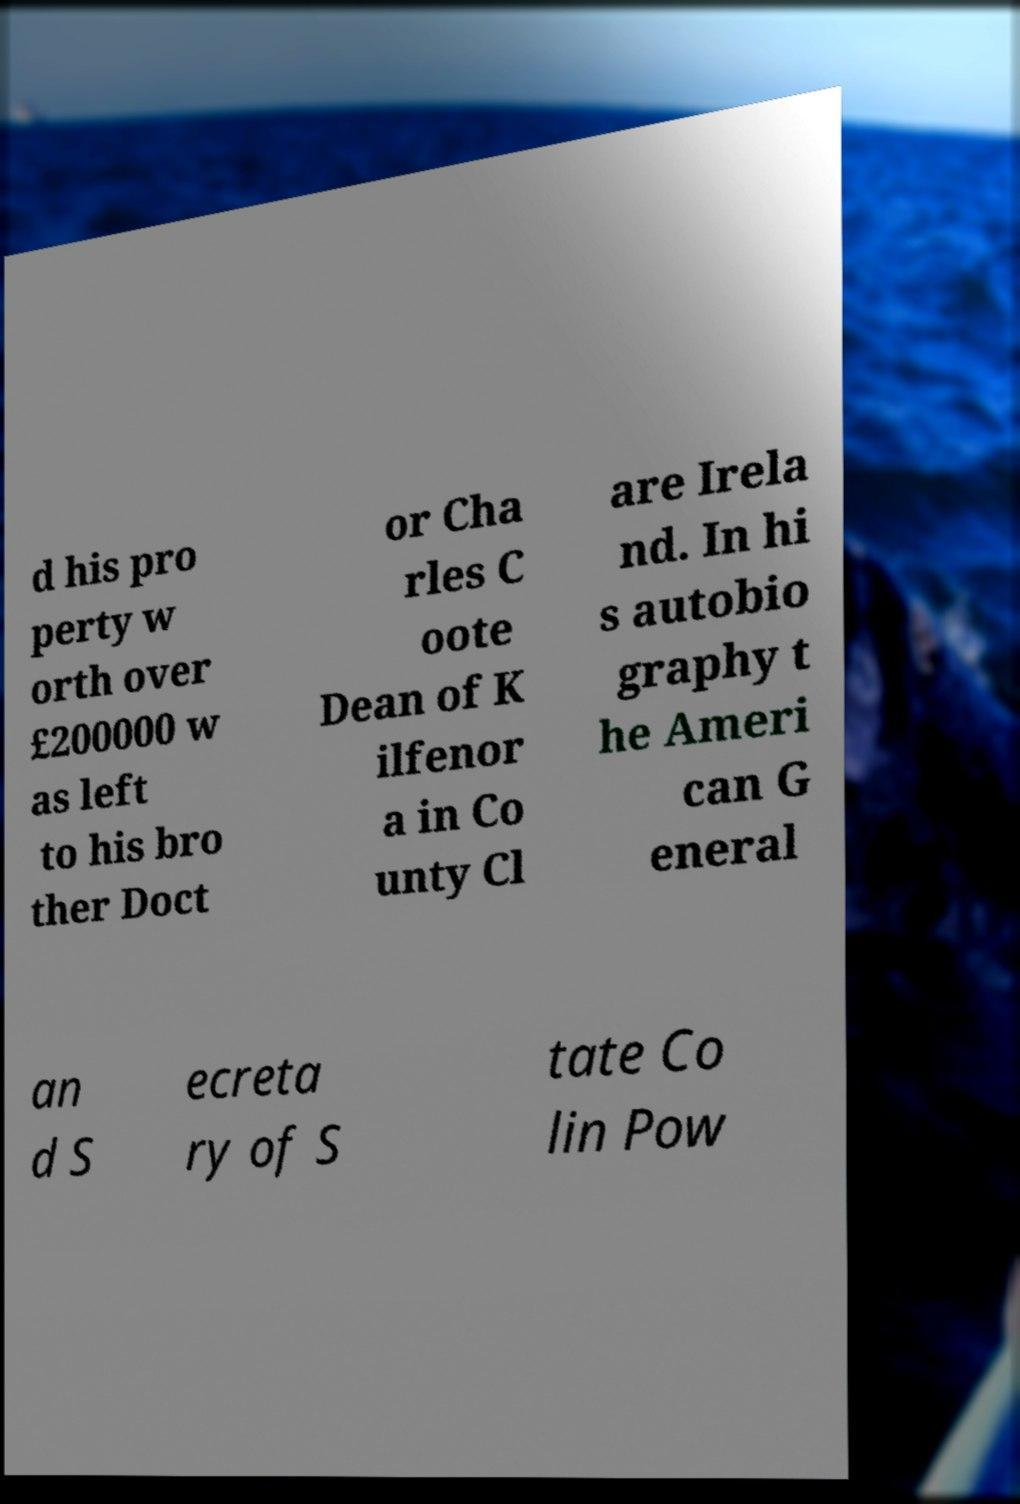Can you accurately transcribe the text from the provided image for me? d his pro perty w orth over £200000 w as left to his bro ther Doct or Cha rles C oote Dean of K ilfenor a in Co unty Cl are Irela nd. In hi s autobio graphy t he Ameri can G eneral an d S ecreta ry of S tate Co lin Pow 